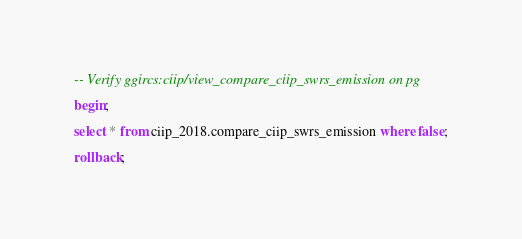Convert code to text. <code><loc_0><loc_0><loc_500><loc_500><_SQL_>-- Verify ggircs:ciip/view_compare_ciip_swrs_emission on pg

begin;

select * from ciip_2018.compare_ciip_swrs_emission where false;

rollback;
</code> 